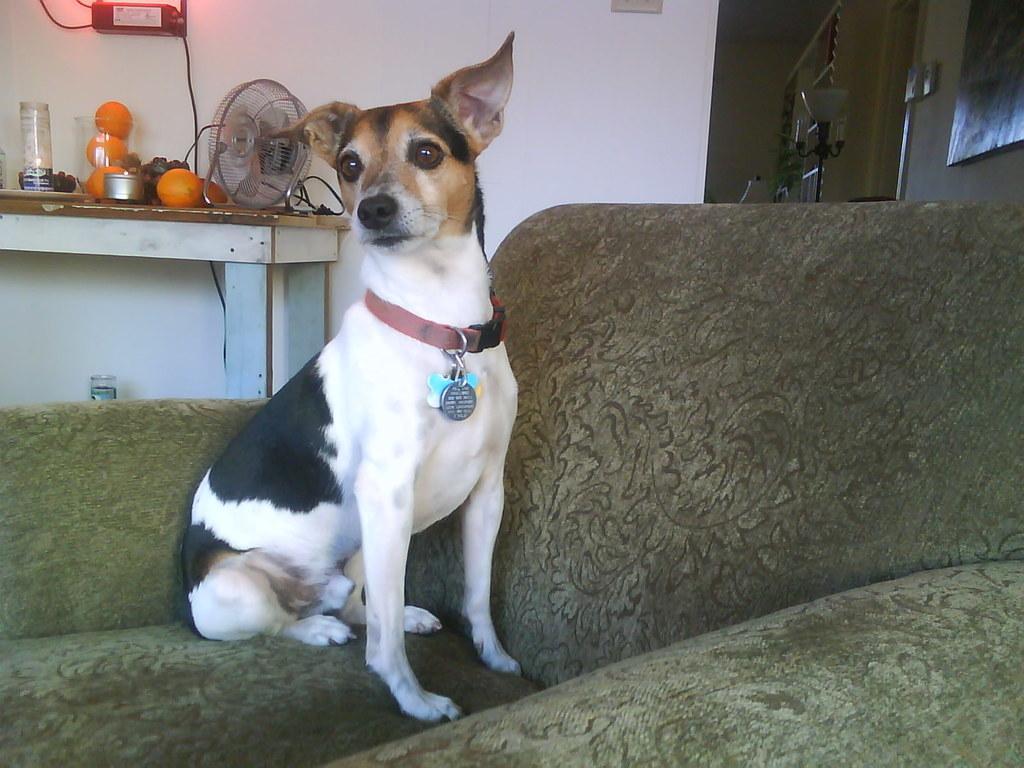How would you summarize this image in a sentence or two? In this image, we can see a dog sitting on the sofa, in the background there is a table, on that table there are some oranges, there is a small fan on the table, we can see a wall. 